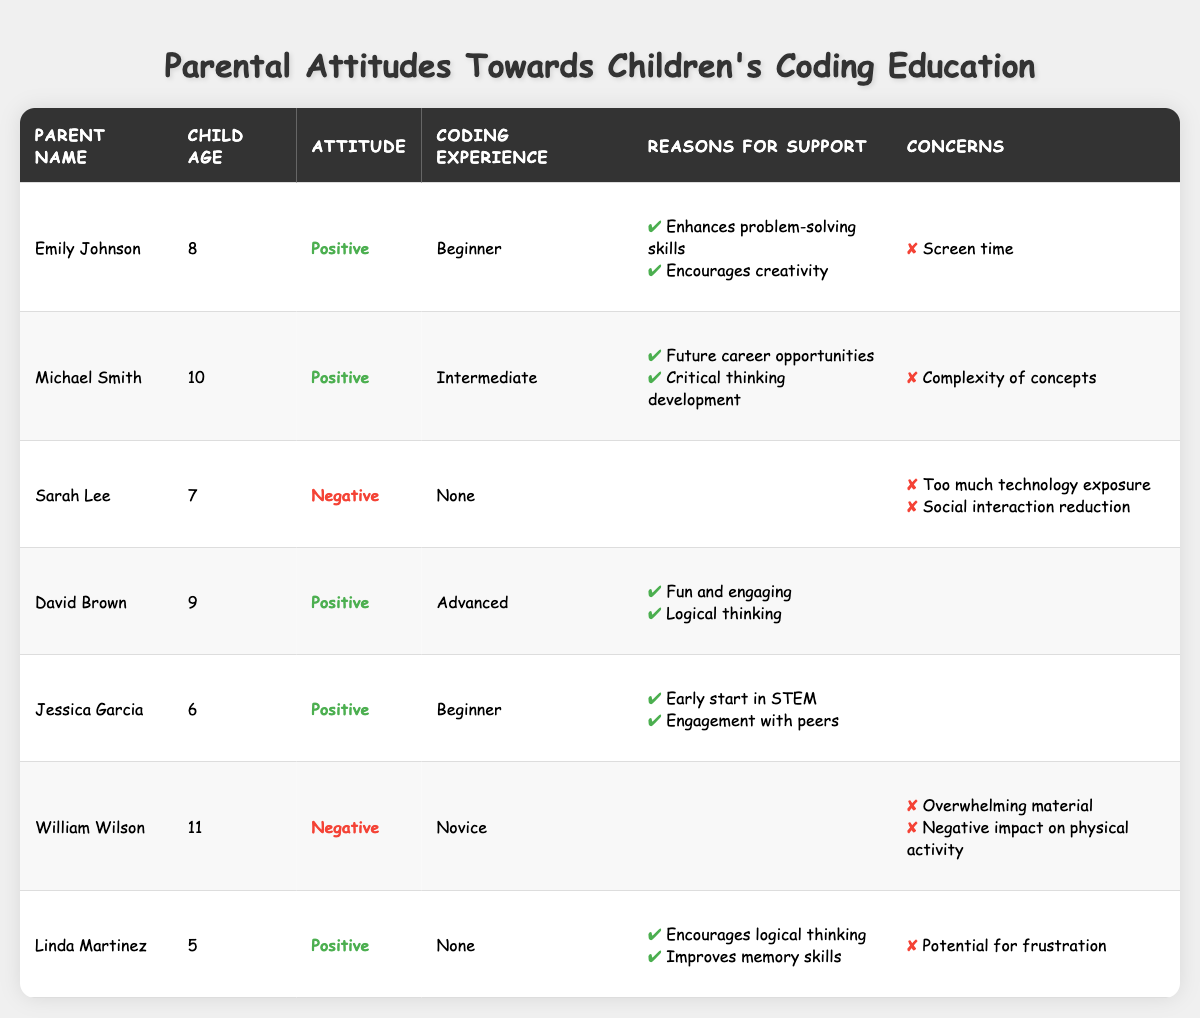What percentage of parents have a positive attitude towards coding education? There are 7 parents in total, and 5 of them have a positive attitude. To find the percentage, divide 5 by 7 and multiply by 100: (5/7) * 100 ≈ 71.43%.
Answer: Approximately 71.43% How many parents express concerns about screen time? Only one parent, Emily Johnson, mentions screen time as a concern.
Answer: 1 Which parent has the oldest child, and what is their child's age? William Wilson has the oldest child, who is 11 years old.
Answer: William Wilson, 11 What are the reasons for support listed by David Brown for coding education? David Brown cites "Fun and engaging" and "Logical thinking" as reasons for support.
Answer: Fun and engaging, Logical thinking What is the coding experience level of parents with a negative attitude? There are two parents with a negative attitude: Sarah Lee with "None" and William Wilson with "Novice."
Answer: None, Novice How many parents have no coding experience but support coding education? Linda Martinez has no coding experience but supports coding education, thus there is one parent fitting this criterion.
Answer: 1 What is the average age of children whose parents have a positive attitude towards coding education? The ages of the children with positive attitudes are 8, 10, 9, 6, and 5. The sum of these ages is (8 + 10 + 9 + 6 + 5) = 38, and the average is 38/5 = 7.6.
Answer: 7.6 Which two parents mention reasons related to logical thinking? David Brown and Linda Martinez mention reasons related to logical thinking.
Answer: David Brown, Linda Martinez Are any parents concerned about the complexity of coding concepts? Yes, Michael Smith has concerns about the complexity of concepts.
Answer: Yes Is there a parent who has a positive attitude and lists no concerns? Yes, both David Brown and Jessica Garcia have a positive attitude and list no concerns.
Answer: Yes 